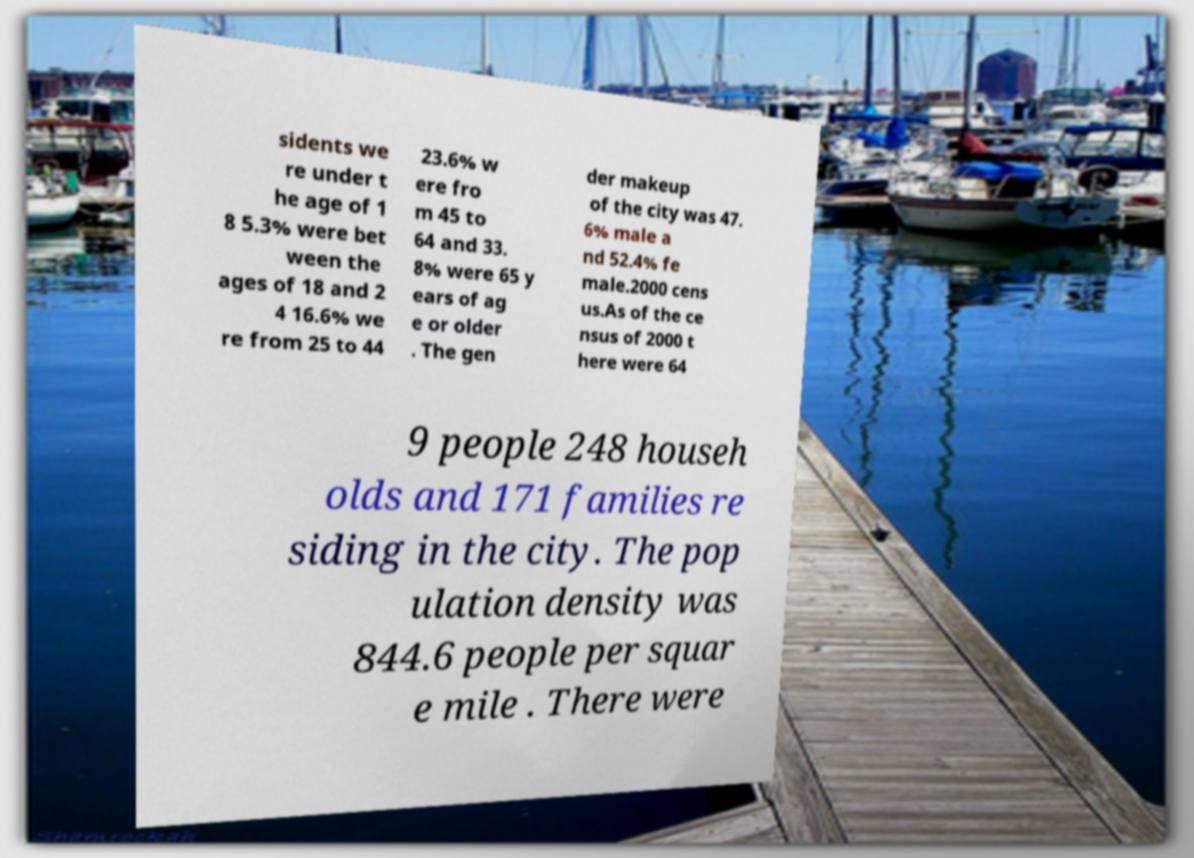Please read and relay the text visible in this image. What does it say? sidents we re under t he age of 1 8 5.3% were bet ween the ages of 18 and 2 4 16.6% we re from 25 to 44 23.6% w ere fro m 45 to 64 and 33. 8% were 65 y ears of ag e or older . The gen der makeup of the city was 47. 6% male a nd 52.4% fe male.2000 cens us.As of the ce nsus of 2000 t here were 64 9 people 248 househ olds and 171 families re siding in the city. The pop ulation density was 844.6 people per squar e mile . There were 